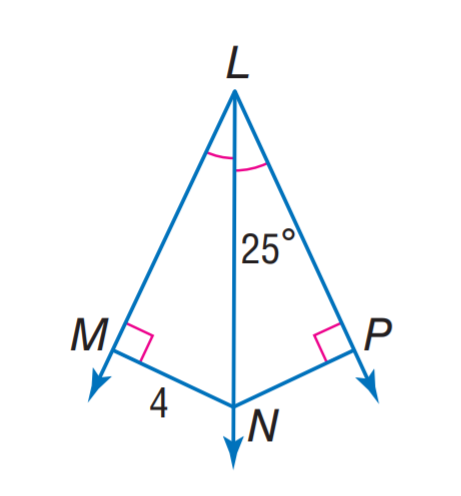Question: Find m \angle M N P.
Choices:
A. 40
B. 50
C. 130
D. 140
Answer with the letter. Answer: C 